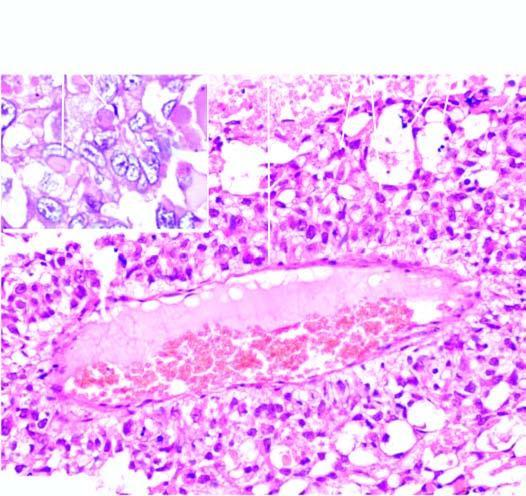what shows intra - and extracellular hyaline globules?
Answer the question using a single word or phrase. Inset 